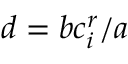<formula> <loc_0><loc_0><loc_500><loc_500>d = b c _ { i } ^ { r } / a</formula> 